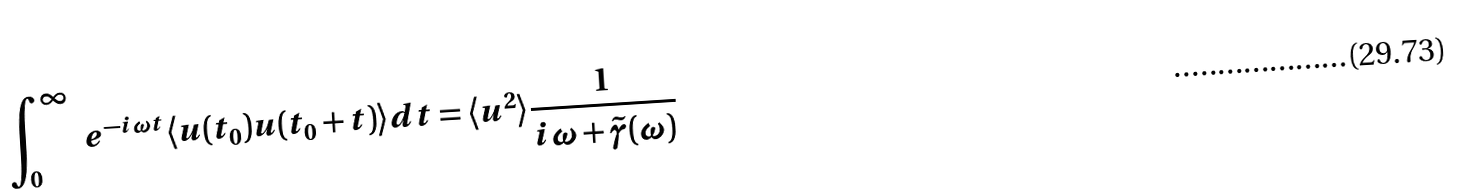<formula> <loc_0><loc_0><loc_500><loc_500>\int _ { 0 } ^ { \infty } \ e ^ { - i \omega t } \langle u ( t _ { 0 } ) u ( t _ { 0 } + t ) \rangle d t = \langle u ^ { 2 } \rangle \frac { 1 } { i \omega + \tilde { \gamma } ( \omega ) }</formula> 